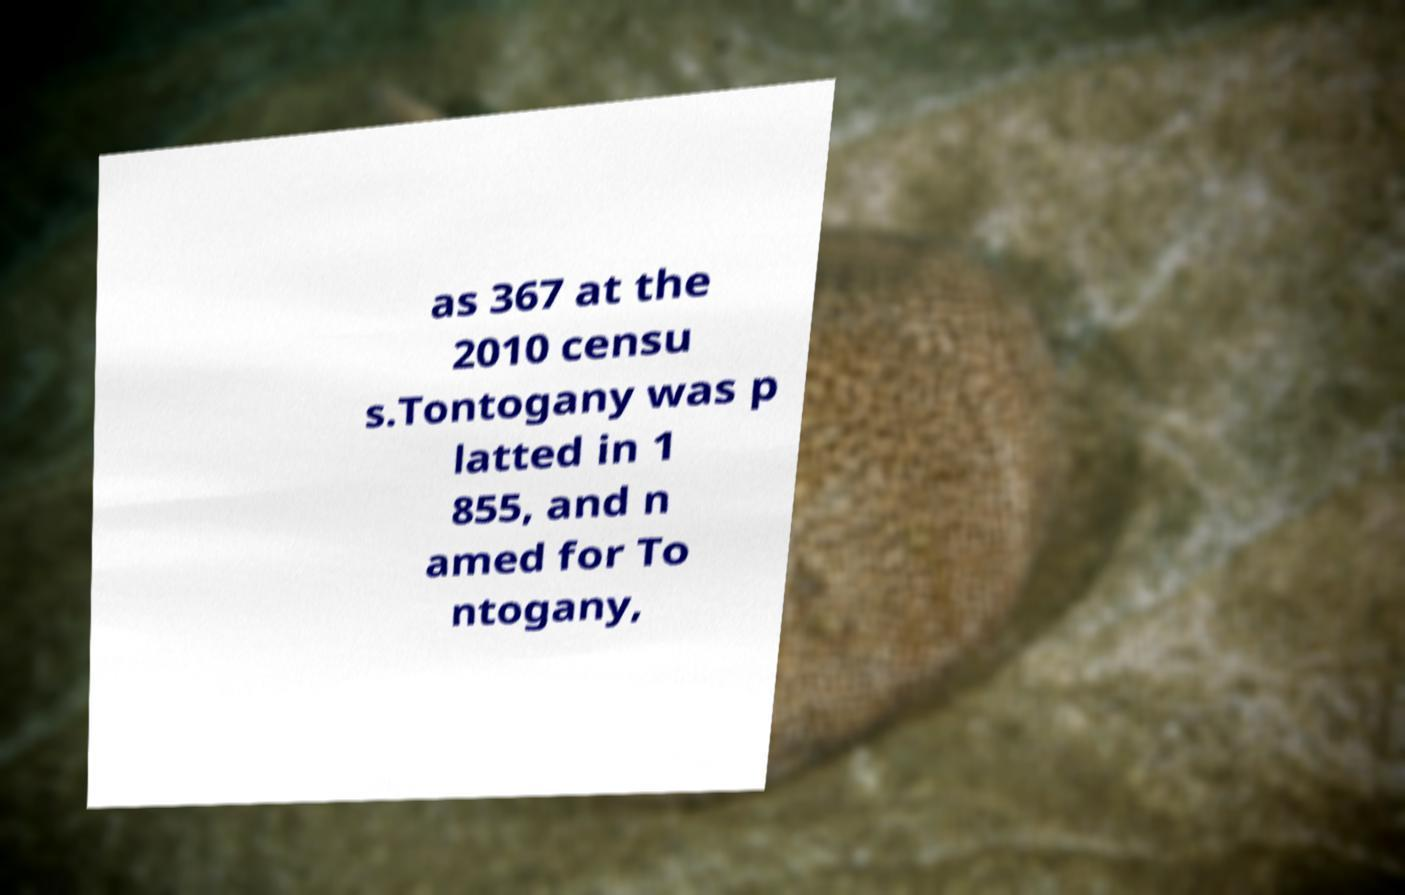For documentation purposes, I need the text within this image transcribed. Could you provide that? as 367 at the 2010 censu s.Tontogany was p latted in 1 855, and n amed for To ntogany, 